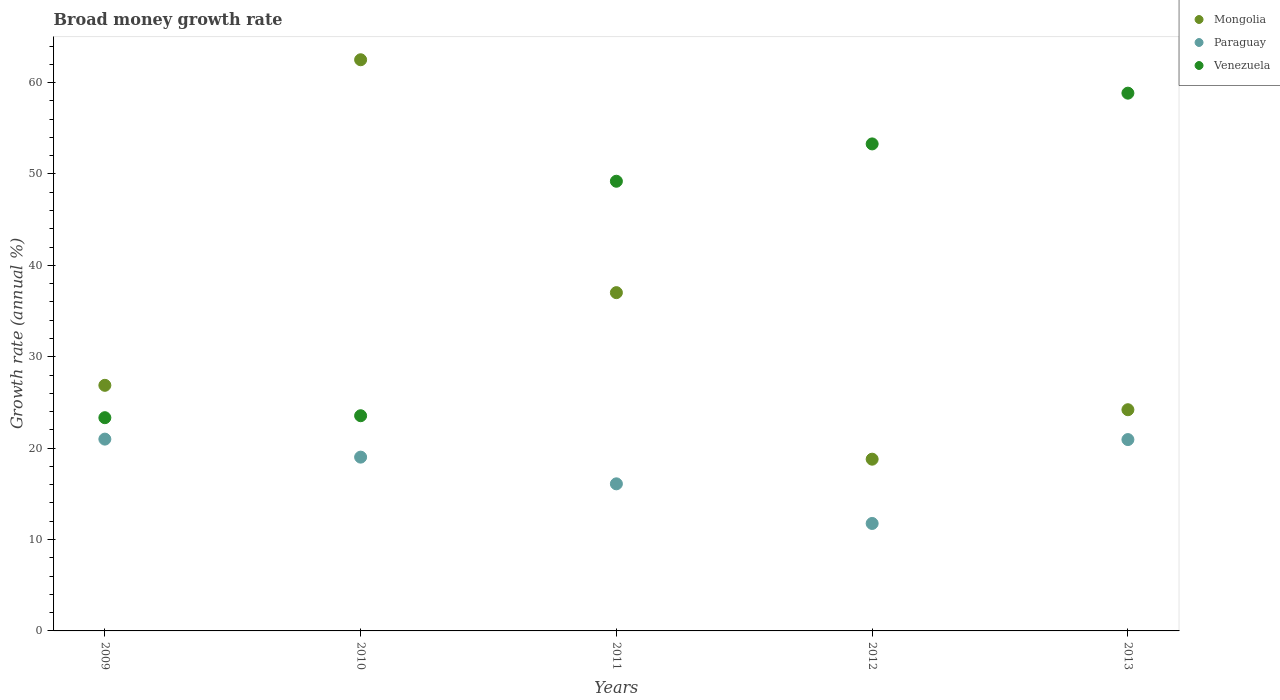How many different coloured dotlines are there?
Make the answer very short. 3. Is the number of dotlines equal to the number of legend labels?
Provide a succinct answer. Yes. What is the growth rate in Paraguay in 2010?
Ensure brevity in your answer.  19.02. Across all years, what is the maximum growth rate in Venezuela?
Your answer should be compact. 58.84. Across all years, what is the minimum growth rate in Venezuela?
Give a very brief answer. 23.33. What is the total growth rate in Paraguay in the graph?
Keep it short and to the point. 88.79. What is the difference between the growth rate in Mongolia in 2012 and that in 2013?
Provide a short and direct response. -5.41. What is the difference between the growth rate in Mongolia in 2010 and the growth rate in Paraguay in 2012?
Provide a short and direct response. 50.74. What is the average growth rate in Paraguay per year?
Give a very brief answer. 17.76. In the year 2010, what is the difference between the growth rate in Paraguay and growth rate in Mongolia?
Offer a terse response. -43.48. What is the ratio of the growth rate in Mongolia in 2009 to that in 2011?
Make the answer very short. 0.73. What is the difference between the highest and the second highest growth rate in Venezuela?
Offer a terse response. 5.55. What is the difference between the highest and the lowest growth rate in Mongolia?
Provide a succinct answer. 43.71. In how many years, is the growth rate in Venezuela greater than the average growth rate in Venezuela taken over all years?
Provide a short and direct response. 3. Is it the case that in every year, the sum of the growth rate in Mongolia and growth rate in Venezuela  is greater than the growth rate in Paraguay?
Make the answer very short. Yes. How many dotlines are there?
Offer a terse response. 3. How many years are there in the graph?
Give a very brief answer. 5. What is the difference between two consecutive major ticks on the Y-axis?
Ensure brevity in your answer.  10. Where does the legend appear in the graph?
Ensure brevity in your answer.  Top right. How many legend labels are there?
Offer a very short reply. 3. What is the title of the graph?
Provide a succinct answer. Broad money growth rate. Does "Argentina" appear as one of the legend labels in the graph?
Provide a short and direct response. No. What is the label or title of the Y-axis?
Offer a very short reply. Growth rate (annual %). What is the Growth rate (annual %) in Mongolia in 2009?
Keep it short and to the point. 26.87. What is the Growth rate (annual %) of Paraguay in 2009?
Provide a short and direct response. 20.99. What is the Growth rate (annual %) of Venezuela in 2009?
Offer a terse response. 23.33. What is the Growth rate (annual %) of Mongolia in 2010?
Keep it short and to the point. 62.5. What is the Growth rate (annual %) of Paraguay in 2010?
Make the answer very short. 19.02. What is the Growth rate (annual %) in Venezuela in 2010?
Offer a very short reply. 23.55. What is the Growth rate (annual %) of Mongolia in 2011?
Make the answer very short. 37.01. What is the Growth rate (annual %) in Paraguay in 2011?
Keep it short and to the point. 16.09. What is the Growth rate (annual %) in Venezuela in 2011?
Keep it short and to the point. 49.2. What is the Growth rate (annual %) of Mongolia in 2012?
Ensure brevity in your answer.  18.79. What is the Growth rate (annual %) of Paraguay in 2012?
Offer a very short reply. 11.76. What is the Growth rate (annual %) in Venezuela in 2012?
Give a very brief answer. 53.29. What is the Growth rate (annual %) in Mongolia in 2013?
Your answer should be very brief. 24.2. What is the Growth rate (annual %) in Paraguay in 2013?
Offer a terse response. 20.94. What is the Growth rate (annual %) in Venezuela in 2013?
Make the answer very short. 58.84. Across all years, what is the maximum Growth rate (annual %) of Mongolia?
Offer a very short reply. 62.5. Across all years, what is the maximum Growth rate (annual %) of Paraguay?
Offer a terse response. 20.99. Across all years, what is the maximum Growth rate (annual %) in Venezuela?
Provide a succinct answer. 58.84. Across all years, what is the minimum Growth rate (annual %) of Mongolia?
Offer a terse response. 18.79. Across all years, what is the minimum Growth rate (annual %) in Paraguay?
Your answer should be compact. 11.76. Across all years, what is the minimum Growth rate (annual %) in Venezuela?
Offer a terse response. 23.33. What is the total Growth rate (annual %) of Mongolia in the graph?
Provide a succinct answer. 169.38. What is the total Growth rate (annual %) in Paraguay in the graph?
Your answer should be compact. 88.79. What is the total Growth rate (annual %) of Venezuela in the graph?
Provide a short and direct response. 208.22. What is the difference between the Growth rate (annual %) in Mongolia in 2009 and that in 2010?
Provide a succinct answer. -35.62. What is the difference between the Growth rate (annual %) of Paraguay in 2009 and that in 2010?
Provide a succinct answer. 1.97. What is the difference between the Growth rate (annual %) in Venezuela in 2009 and that in 2010?
Your answer should be very brief. -0.21. What is the difference between the Growth rate (annual %) in Mongolia in 2009 and that in 2011?
Give a very brief answer. -10.14. What is the difference between the Growth rate (annual %) of Paraguay in 2009 and that in 2011?
Offer a terse response. 4.89. What is the difference between the Growth rate (annual %) of Venezuela in 2009 and that in 2011?
Offer a very short reply. -25.87. What is the difference between the Growth rate (annual %) of Mongolia in 2009 and that in 2012?
Offer a very short reply. 8.08. What is the difference between the Growth rate (annual %) in Paraguay in 2009 and that in 2012?
Your answer should be compact. 9.23. What is the difference between the Growth rate (annual %) of Venezuela in 2009 and that in 2012?
Give a very brief answer. -29.96. What is the difference between the Growth rate (annual %) of Mongolia in 2009 and that in 2013?
Your answer should be compact. 2.67. What is the difference between the Growth rate (annual %) of Paraguay in 2009 and that in 2013?
Make the answer very short. 0.05. What is the difference between the Growth rate (annual %) of Venezuela in 2009 and that in 2013?
Offer a terse response. -35.51. What is the difference between the Growth rate (annual %) of Mongolia in 2010 and that in 2011?
Your response must be concise. 25.48. What is the difference between the Growth rate (annual %) in Paraguay in 2010 and that in 2011?
Make the answer very short. 2.92. What is the difference between the Growth rate (annual %) of Venezuela in 2010 and that in 2011?
Your answer should be compact. -25.66. What is the difference between the Growth rate (annual %) in Mongolia in 2010 and that in 2012?
Your answer should be compact. 43.71. What is the difference between the Growth rate (annual %) of Paraguay in 2010 and that in 2012?
Keep it short and to the point. 7.26. What is the difference between the Growth rate (annual %) in Venezuela in 2010 and that in 2012?
Offer a terse response. -29.74. What is the difference between the Growth rate (annual %) in Mongolia in 2010 and that in 2013?
Your response must be concise. 38.29. What is the difference between the Growth rate (annual %) in Paraguay in 2010 and that in 2013?
Your answer should be very brief. -1.92. What is the difference between the Growth rate (annual %) in Venezuela in 2010 and that in 2013?
Give a very brief answer. -35.3. What is the difference between the Growth rate (annual %) in Mongolia in 2011 and that in 2012?
Ensure brevity in your answer.  18.22. What is the difference between the Growth rate (annual %) of Paraguay in 2011 and that in 2012?
Ensure brevity in your answer.  4.34. What is the difference between the Growth rate (annual %) in Venezuela in 2011 and that in 2012?
Your response must be concise. -4.09. What is the difference between the Growth rate (annual %) of Mongolia in 2011 and that in 2013?
Give a very brief answer. 12.81. What is the difference between the Growth rate (annual %) of Paraguay in 2011 and that in 2013?
Give a very brief answer. -4.84. What is the difference between the Growth rate (annual %) of Venezuela in 2011 and that in 2013?
Your answer should be very brief. -9.64. What is the difference between the Growth rate (annual %) of Mongolia in 2012 and that in 2013?
Make the answer very short. -5.41. What is the difference between the Growth rate (annual %) in Paraguay in 2012 and that in 2013?
Make the answer very short. -9.18. What is the difference between the Growth rate (annual %) of Venezuela in 2012 and that in 2013?
Make the answer very short. -5.55. What is the difference between the Growth rate (annual %) in Mongolia in 2009 and the Growth rate (annual %) in Paraguay in 2010?
Make the answer very short. 7.86. What is the difference between the Growth rate (annual %) of Mongolia in 2009 and the Growth rate (annual %) of Venezuela in 2010?
Provide a short and direct response. 3.33. What is the difference between the Growth rate (annual %) in Paraguay in 2009 and the Growth rate (annual %) in Venezuela in 2010?
Ensure brevity in your answer.  -2.56. What is the difference between the Growth rate (annual %) of Mongolia in 2009 and the Growth rate (annual %) of Paraguay in 2011?
Your answer should be very brief. 10.78. What is the difference between the Growth rate (annual %) of Mongolia in 2009 and the Growth rate (annual %) of Venezuela in 2011?
Make the answer very short. -22.33. What is the difference between the Growth rate (annual %) in Paraguay in 2009 and the Growth rate (annual %) in Venezuela in 2011?
Make the answer very short. -28.22. What is the difference between the Growth rate (annual %) in Mongolia in 2009 and the Growth rate (annual %) in Paraguay in 2012?
Offer a terse response. 15.12. What is the difference between the Growth rate (annual %) in Mongolia in 2009 and the Growth rate (annual %) in Venezuela in 2012?
Make the answer very short. -26.42. What is the difference between the Growth rate (annual %) of Paraguay in 2009 and the Growth rate (annual %) of Venezuela in 2012?
Make the answer very short. -32.3. What is the difference between the Growth rate (annual %) in Mongolia in 2009 and the Growth rate (annual %) in Paraguay in 2013?
Your response must be concise. 5.94. What is the difference between the Growth rate (annual %) of Mongolia in 2009 and the Growth rate (annual %) of Venezuela in 2013?
Provide a short and direct response. -31.97. What is the difference between the Growth rate (annual %) of Paraguay in 2009 and the Growth rate (annual %) of Venezuela in 2013?
Offer a terse response. -37.86. What is the difference between the Growth rate (annual %) in Mongolia in 2010 and the Growth rate (annual %) in Paraguay in 2011?
Your response must be concise. 46.4. What is the difference between the Growth rate (annual %) of Mongolia in 2010 and the Growth rate (annual %) of Venezuela in 2011?
Ensure brevity in your answer.  13.29. What is the difference between the Growth rate (annual %) in Paraguay in 2010 and the Growth rate (annual %) in Venezuela in 2011?
Provide a succinct answer. -30.19. What is the difference between the Growth rate (annual %) in Mongolia in 2010 and the Growth rate (annual %) in Paraguay in 2012?
Ensure brevity in your answer.  50.74. What is the difference between the Growth rate (annual %) of Mongolia in 2010 and the Growth rate (annual %) of Venezuela in 2012?
Your response must be concise. 9.21. What is the difference between the Growth rate (annual %) in Paraguay in 2010 and the Growth rate (annual %) in Venezuela in 2012?
Provide a succinct answer. -34.27. What is the difference between the Growth rate (annual %) in Mongolia in 2010 and the Growth rate (annual %) in Paraguay in 2013?
Provide a succinct answer. 41.56. What is the difference between the Growth rate (annual %) of Mongolia in 2010 and the Growth rate (annual %) of Venezuela in 2013?
Your answer should be very brief. 3.65. What is the difference between the Growth rate (annual %) of Paraguay in 2010 and the Growth rate (annual %) of Venezuela in 2013?
Your response must be concise. -39.83. What is the difference between the Growth rate (annual %) of Mongolia in 2011 and the Growth rate (annual %) of Paraguay in 2012?
Your answer should be very brief. 25.26. What is the difference between the Growth rate (annual %) of Mongolia in 2011 and the Growth rate (annual %) of Venezuela in 2012?
Keep it short and to the point. -16.28. What is the difference between the Growth rate (annual %) in Paraguay in 2011 and the Growth rate (annual %) in Venezuela in 2012?
Offer a terse response. -37.2. What is the difference between the Growth rate (annual %) of Mongolia in 2011 and the Growth rate (annual %) of Paraguay in 2013?
Offer a terse response. 16.08. What is the difference between the Growth rate (annual %) of Mongolia in 2011 and the Growth rate (annual %) of Venezuela in 2013?
Provide a short and direct response. -21.83. What is the difference between the Growth rate (annual %) of Paraguay in 2011 and the Growth rate (annual %) of Venezuela in 2013?
Offer a terse response. -42.75. What is the difference between the Growth rate (annual %) in Mongolia in 2012 and the Growth rate (annual %) in Paraguay in 2013?
Offer a very short reply. -2.14. What is the difference between the Growth rate (annual %) in Mongolia in 2012 and the Growth rate (annual %) in Venezuela in 2013?
Offer a terse response. -40.05. What is the difference between the Growth rate (annual %) of Paraguay in 2012 and the Growth rate (annual %) of Venezuela in 2013?
Give a very brief answer. -47.08. What is the average Growth rate (annual %) in Mongolia per year?
Your response must be concise. 33.88. What is the average Growth rate (annual %) of Paraguay per year?
Your answer should be compact. 17.76. What is the average Growth rate (annual %) in Venezuela per year?
Provide a short and direct response. 41.64. In the year 2009, what is the difference between the Growth rate (annual %) of Mongolia and Growth rate (annual %) of Paraguay?
Provide a succinct answer. 5.89. In the year 2009, what is the difference between the Growth rate (annual %) of Mongolia and Growth rate (annual %) of Venezuela?
Offer a very short reply. 3.54. In the year 2009, what is the difference between the Growth rate (annual %) in Paraguay and Growth rate (annual %) in Venezuela?
Provide a succinct answer. -2.34. In the year 2010, what is the difference between the Growth rate (annual %) of Mongolia and Growth rate (annual %) of Paraguay?
Make the answer very short. 43.48. In the year 2010, what is the difference between the Growth rate (annual %) in Mongolia and Growth rate (annual %) in Venezuela?
Ensure brevity in your answer.  38.95. In the year 2010, what is the difference between the Growth rate (annual %) in Paraguay and Growth rate (annual %) in Venezuela?
Make the answer very short. -4.53. In the year 2011, what is the difference between the Growth rate (annual %) of Mongolia and Growth rate (annual %) of Paraguay?
Your answer should be very brief. 20.92. In the year 2011, what is the difference between the Growth rate (annual %) in Mongolia and Growth rate (annual %) in Venezuela?
Provide a short and direct response. -12.19. In the year 2011, what is the difference between the Growth rate (annual %) in Paraguay and Growth rate (annual %) in Venezuela?
Offer a terse response. -33.11. In the year 2012, what is the difference between the Growth rate (annual %) of Mongolia and Growth rate (annual %) of Paraguay?
Your answer should be very brief. 7.03. In the year 2012, what is the difference between the Growth rate (annual %) of Mongolia and Growth rate (annual %) of Venezuela?
Ensure brevity in your answer.  -34.5. In the year 2012, what is the difference between the Growth rate (annual %) of Paraguay and Growth rate (annual %) of Venezuela?
Provide a succinct answer. -41.53. In the year 2013, what is the difference between the Growth rate (annual %) in Mongolia and Growth rate (annual %) in Paraguay?
Your answer should be very brief. 3.27. In the year 2013, what is the difference between the Growth rate (annual %) of Mongolia and Growth rate (annual %) of Venezuela?
Offer a terse response. -34.64. In the year 2013, what is the difference between the Growth rate (annual %) in Paraguay and Growth rate (annual %) in Venezuela?
Provide a short and direct response. -37.91. What is the ratio of the Growth rate (annual %) of Mongolia in 2009 to that in 2010?
Make the answer very short. 0.43. What is the ratio of the Growth rate (annual %) in Paraguay in 2009 to that in 2010?
Make the answer very short. 1.1. What is the ratio of the Growth rate (annual %) in Venezuela in 2009 to that in 2010?
Ensure brevity in your answer.  0.99. What is the ratio of the Growth rate (annual %) of Mongolia in 2009 to that in 2011?
Your response must be concise. 0.73. What is the ratio of the Growth rate (annual %) in Paraguay in 2009 to that in 2011?
Your answer should be compact. 1.3. What is the ratio of the Growth rate (annual %) of Venezuela in 2009 to that in 2011?
Your answer should be compact. 0.47. What is the ratio of the Growth rate (annual %) of Mongolia in 2009 to that in 2012?
Your response must be concise. 1.43. What is the ratio of the Growth rate (annual %) of Paraguay in 2009 to that in 2012?
Ensure brevity in your answer.  1.78. What is the ratio of the Growth rate (annual %) in Venezuela in 2009 to that in 2012?
Your answer should be compact. 0.44. What is the ratio of the Growth rate (annual %) in Mongolia in 2009 to that in 2013?
Your answer should be compact. 1.11. What is the ratio of the Growth rate (annual %) in Venezuela in 2009 to that in 2013?
Make the answer very short. 0.4. What is the ratio of the Growth rate (annual %) of Mongolia in 2010 to that in 2011?
Provide a short and direct response. 1.69. What is the ratio of the Growth rate (annual %) of Paraguay in 2010 to that in 2011?
Keep it short and to the point. 1.18. What is the ratio of the Growth rate (annual %) in Venezuela in 2010 to that in 2011?
Offer a terse response. 0.48. What is the ratio of the Growth rate (annual %) in Mongolia in 2010 to that in 2012?
Your answer should be compact. 3.33. What is the ratio of the Growth rate (annual %) in Paraguay in 2010 to that in 2012?
Make the answer very short. 1.62. What is the ratio of the Growth rate (annual %) of Venezuela in 2010 to that in 2012?
Keep it short and to the point. 0.44. What is the ratio of the Growth rate (annual %) of Mongolia in 2010 to that in 2013?
Your answer should be very brief. 2.58. What is the ratio of the Growth rate (annual %) of Paraguay in 2010 to that in 2013?
Offer a very short reply. 0.91. What is the ratio of the Growth rate (annual %) of Venezuela in 2010 to that in 2013?
Your answer should be compact. 0.4. What is the ratio of the Growth rate (annual %) of Mongolia in 2011 to that in 2012?
Provide a short and direct response. 1.97. What is the ratio of the Growth rate (annual %) in Paraguay in 2011 to that in 2012?
Ensure brevity in your answer.  1.37. What is the ratio of the Growth rate (annual %) in Venezuela in 2011 to that in 2012?
Give a very brief answer. 0.92. What is the ratio of the Growth rate (annual %) of Mongolia in 2011 to that in 2013?
Provide a short and direct response. 1.53. What is the ratio of the Growth rate (annual %) of Paraguay in 2011 to that in 2013?
Give a very brief answer. 0.77. What is the ratio of the Growth rate (annual %) in Venezuela in 2011 to that in 2013?
Your answer should be compact. 0.84. What is the ratio of the Growth rate (annual %) in Mongolia in 2012 to that in 2013?
Make the answer very short. 0.78. What is the ratio of the Growth rate (annual %) in Paraguay in 2012 to that in 2013?
Give a very brief answer. 0.56. What is the ratio of the Growth rate (annual %) of Venezuela in 2012 to that in 2013?
Your response must be concise. 0.91. What is the difference between the highest and the second highest Growth rate (annual %) in Mongolia?
Provide a short and direct response. 25.48. What is the difference between the highest and the second highest Growth rate (annual %) in Paraguay?
Give a very brief answer. 0.05. What is the difference between the highest and the second highest Growth rate (annual %) in Venezuela?
Ensure brevity in your answer.  5.55. What is the difference between the highest and the lowest Growth rate (annual %) of Mongolia?
Ensure brevity in your answer.  43.71. What is the difference between the highest and the lowest Growth rate (annual %) of Paraguay?
Give a very brief answer. 9.23. What is the difference between the highest and the lowest Growth rate (annual %) in Venezuela?
Make the answer very short. 35.51. 